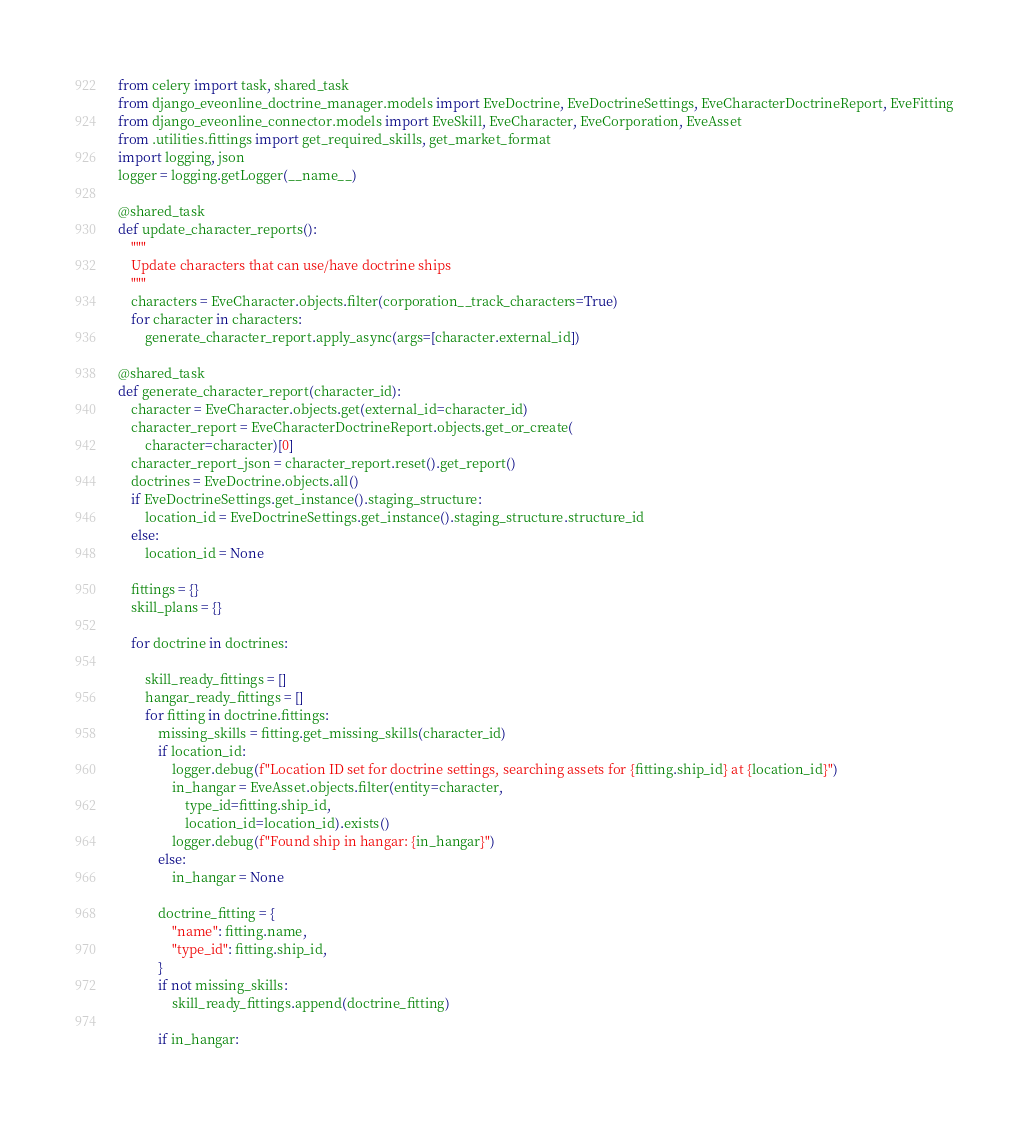Convert code to text. <code><loc_0><loc_0><loc_500><loc_500><_Python_>from celery import task, shared_task
from django_eveonline_doctrine_manager.models import EveDoctrine, EveDoctrineSettings, EveCharacterDoctrineReport, EveFitting
from django_eveonline_connector.models import EveSkill, EveCharacter, EveCorporation, EveAsset
from .utilities.fittings import get_required_skills, get_market_format
import logging, json
logger = logging.getLogger(__name__)

@shared_task
def update_character_reports():
    """
    Update characters that can use/have doctrine ships 
    """
    characters = EveCharacter.objects.filter(corporation__track_characters=True)
    for character in characters:
        generate_character_report.apply_async(args=[character.external_id])

@shared_task
def generate_character_report(character_id):
    character = EveCharacter.objects.get(external_id=character_id)
    character_report = EveCharacterDoctrineReport.objects.get_or_create(
        character=character)[0]
    character_report_json = character_report.reset().get_report()
    doctrines = EveDoctrine.objects.all() 
    if EveDoctrineSettings.get_instance().staging_structure:
        location_id = EveDoctrineSettings.get_instance().staging_structure.structure_id 
    else:
        location_id = None

    fittings = {}
    skill_plans = {}

    for doctrine in doctrines:

        skill_ready_fittings = []
        hangar_ready_fittings = []
        for fitting in doctrine.fittings:
            missing_skills = fitting.get_missing_skills(character_id)
            if location_id:
                logger.debug(f"Location ID set for doctrine settings, searching assets for {fitting.ship_id} at {location_id}")
                in_hangar = EveAsset.objects.filter(entity=character, 
                    type_id=fitting.ship_id, 
                    location_id=location_id).exists()
                logger.debug(f"Found ship in hangar: {in_hangar}")
            else:
                in_hangar = None 

            doctrine_fitting = {
                "name": fitting.name,
                "type_id": fitting.ship_id,
            }
            if not missing_skills:
                skill_ready_fittings.append(doctrine_fitting)

            if in_hangar:</code> 